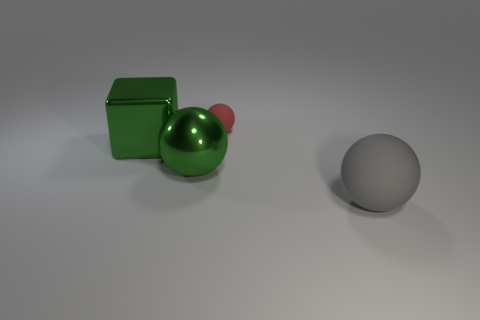Subtract all yellow blocks. Subtract all green balls. How many blocks are left? 1 Add 2 big red cubes. How many objects exist? 6 Subtract all balls. How many objects are left? 1 Subtract 0 red cylinders. How many objects are left? 4 Subtract all gray matte spheres. Subtract all gray matte objects. How many objects are left? 2 Add 3 large green spheres. How many large green spheres are left? 4 Add 1 small things. How many small things exist? 2 